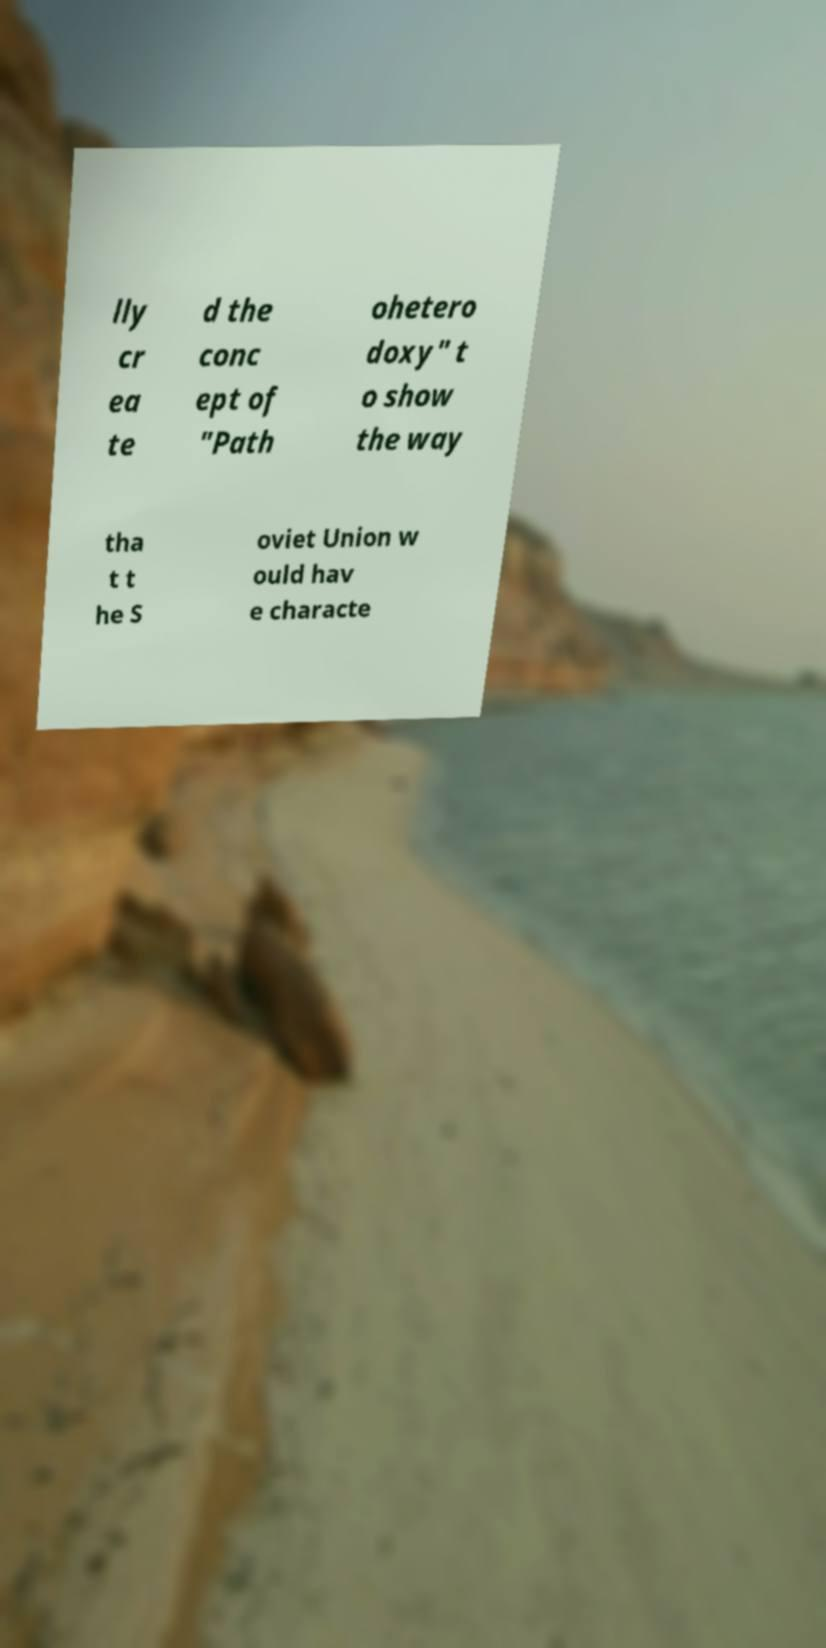There's text embedded in this image that I need extracted. Can you transcribe it verbatim? lly cr ea te d the conc ept of "Path ohetero doxy" t o show the way tha t t he S oviet Union w ould hav e characte 